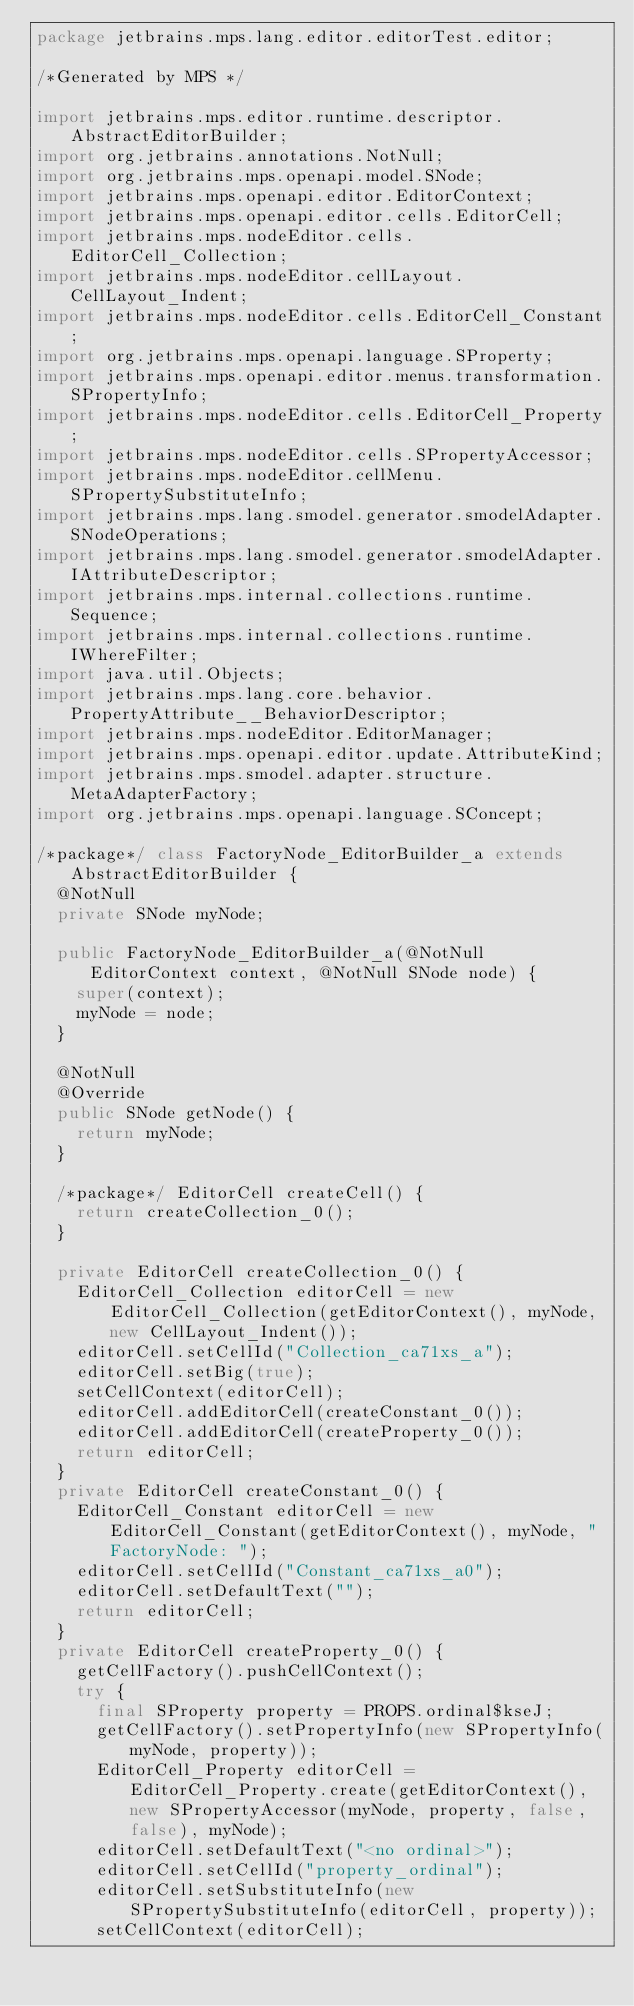Convert code to text. <code><loc_0><loc_0><loc_500><loc_500><_Java_>package jetbrains.mps.lang.editor.editorTest.editor;

/*Generated by MPS */

import jetbrains.mps.editor.runtime.descriptor.AbstractEditorBuilder;
import org.jetbrains.annotations.NotNull;
import org.jetbrains.mps.openapi.model.SNode;
import jetbrains.mps.openapi.editor.EditorContext;
import jetbrains.mps.openapi.editor.cells.EditorCell;
import jetbrains.mps.nodeEditor.cells.EditorCell_Collection;
import jetbrains.mps.nodeEditor.cellLayout.CellLayout_Indent;
import jetbrains.mps.nodeEditor.cells.EditorCell_Constant;
import org.jetbrains.mps.openapi.language.SProperty;
import jetbrains.mps.openapi.editor.menus.transformation.SPropertyInfo;
import jetbrains.mps.nodeEditor.cells.EditorCell_Property;
import jetbrains.mps.nodeEditor.cells.SPropertyAccessor;
import jetbrains.mps.nodeEditor.cellMenu.SPropertySubstituteInfo;
import jetbrains.mps.lang.smodel.generator.smodelAdapter.SNodeOperations;
import jetbrains.mps.lang.smodel.generator.smodelAdapter.IAttributeDescriptor;
import jetbrains.mps.internal.collections.runtime.Sequence;
import jetbrains.mps.internal.collections.runtime.IWhereFilter;
import java.util.Objects;
import jetbrains.mps.lang.core.behavior.PropertyAttribute__BehaviorDescriptor;
import jetbrains.mps.nodeEditor.EditorManager;
import jetbrains.mps.openapi.editor.update.AttributeKind;
import jetbrains.mps.smodel.adapter.structure.MetaAdapterFactory;
import org.jetbrains.mps.openapi.language.SConcept;

/*package*/ class FactoryNode_EditorBuilder_a extends AbstractEditorBuilder {
  @NotNull
  private SNode myNode;

  public FactoryNode_EditorBuilder_a(@NotNull EditorContext context, @NotNull SNode node) {
    super(context);
    myNode = node;
  }

  @NotNull
  @Override
  public SNode getNode() {
    return myNode;
  }

  /*package*/ EditorCell createCell() {
    return createCollection_0();
  }

  private EditorCell createCollection_0() {
    EditorCell_Collection editorCell = new EditorCell_Collection(getEditorContext(), myNode, new CellLayout_Indent());
    editorCell.setCellId("Collection_ca71xs_a");
    editorCell.setBig(true);
    setCellContext(editorCell);
    editorCell.addEditorCell(createConstant_0());
    editorCell.addEditorCell(createProperty_0());
    return editorCell;
  }
  private EditorCell createConstant_0() {
    EditorCell_Constant editorCell = new EditorCell_Constant(getEditorContext(), myNode, "FactoryNode: ");
    editorCell.setCellId("Constant_ca71xs_a0");
    editorCell.setDefaultText("");
    return editorCell;
  }
  private EditorCell createProperty_0() {
    getCellFactory().pushCellContext();
    try {
      final SProperty property = PROPS.ordinal$kseJ;
      getCellFactory().setPropertyInfo(new SPropertyInfo(myNode, property));
      EditorCell_Property editorCell = EditorCell_Property.create(getEditorContext(), new SPropertyAccessor(myNode, property, false, false), myNode);
      editorCell.setDefaultText("<no ordinal>");
      editorCell.setCellId("property_ordinal");
      editorCell.setSubstituteInfo(new SPropertySubstituteInfo(editorCell, property));
      setCellContext(editorCell);</code> 